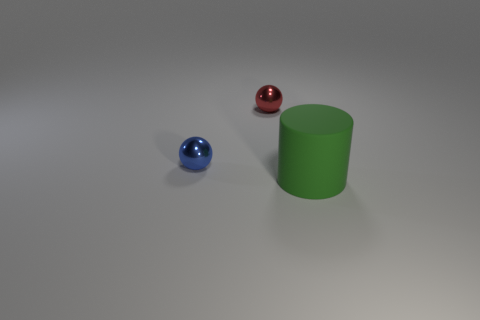Add 1 green matte blocks. How many objects exist? 4 Subtract all balls. How many objects are left? 1 Add 3 red objects. How many red objects are left? 4 Add 1 large red cylinders. How many large red cylinders exist? 1 Subtract 0 purple cylinders. How many objects are left? 3 Subtract all small gray metallic cubes. Subtract all tiny red metal spheres. How many objects are left? 2 